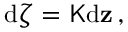<formula> <loc_0><loc_0><loc_500><loc_500>\begin{array} { r } { d \zeta = K d z \, , } \end{array}</formula> 